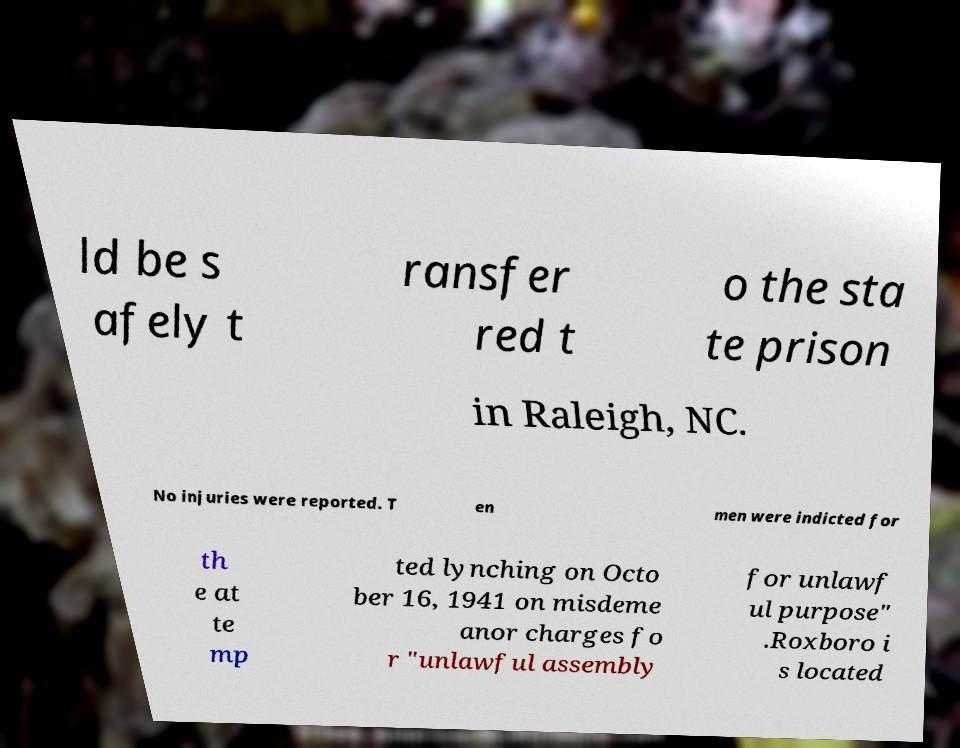Please identify and transcribe the text found in this image. ld be s afely t ransfer red t o the sta te prison in Raleigh, NC. No injuries were reported. T en men were indicted for th e at te mp ted lynching on Octo ber 16, 1941 on misdeme anor charges fo r "unlawful assembly for unlawf ul purpose" .Roxboro i s located 